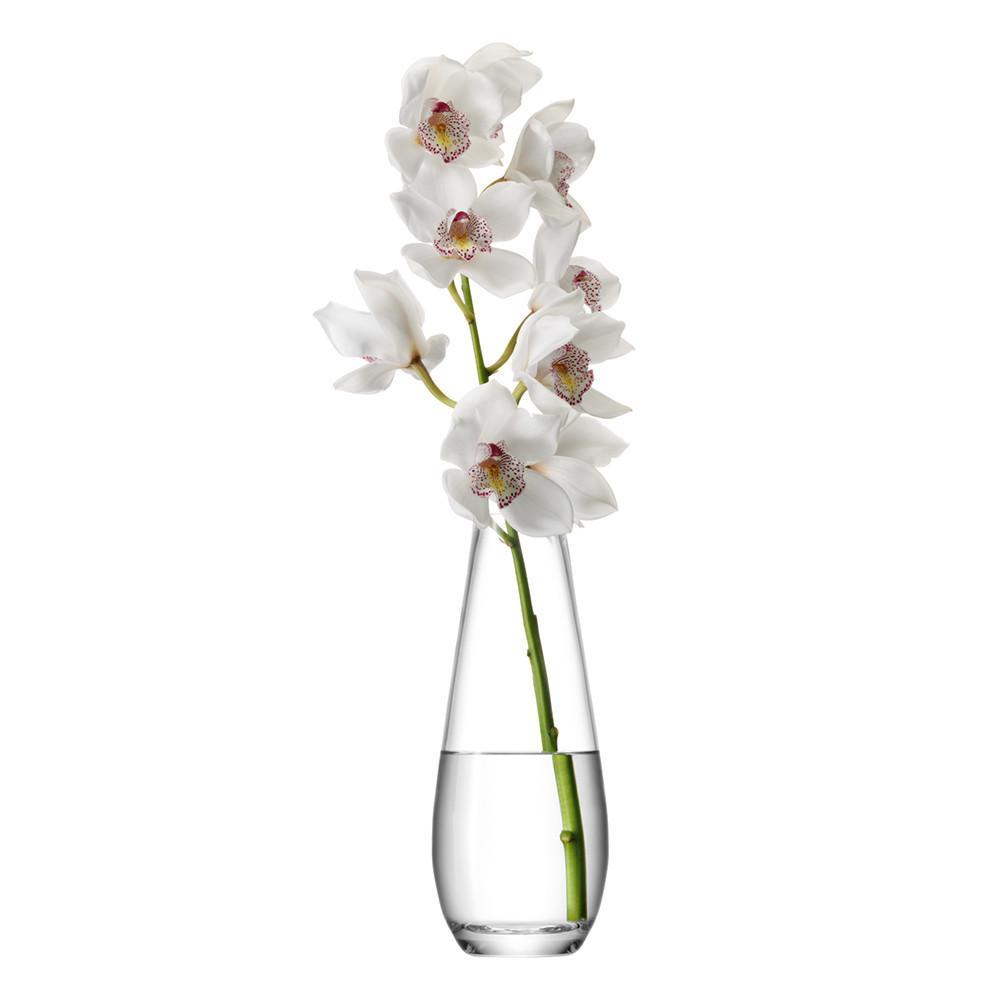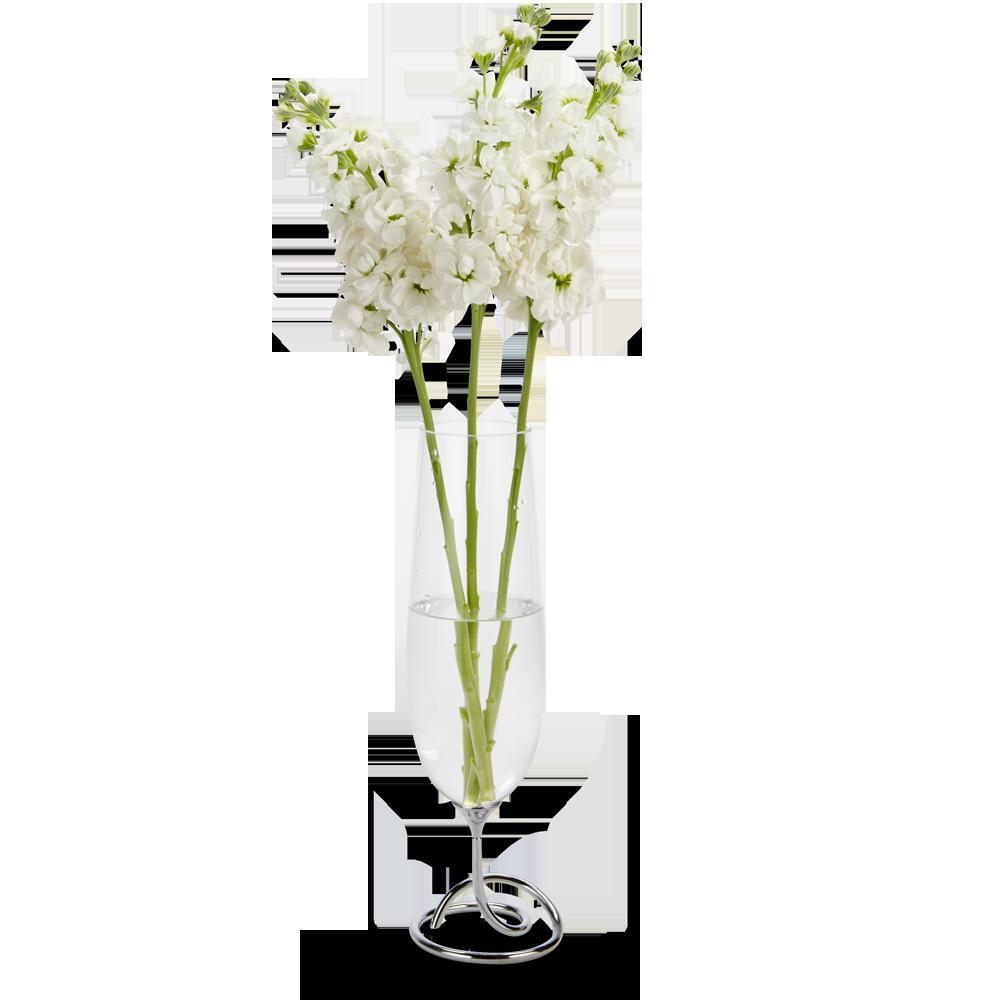The first image is the image on the left, the second image is the image on the right. Examine the images to the left and right. Is the description "The flowers in the clear glass vase are white with green stems." accurate? Answer yes or no. Yes. The first image is the image on the left, the second image is the image on the right. Evaluate the accuracy of this statement regarding the images: "There are two vases with stems that are visible". Is it true? Answer yes or no. Yes. 